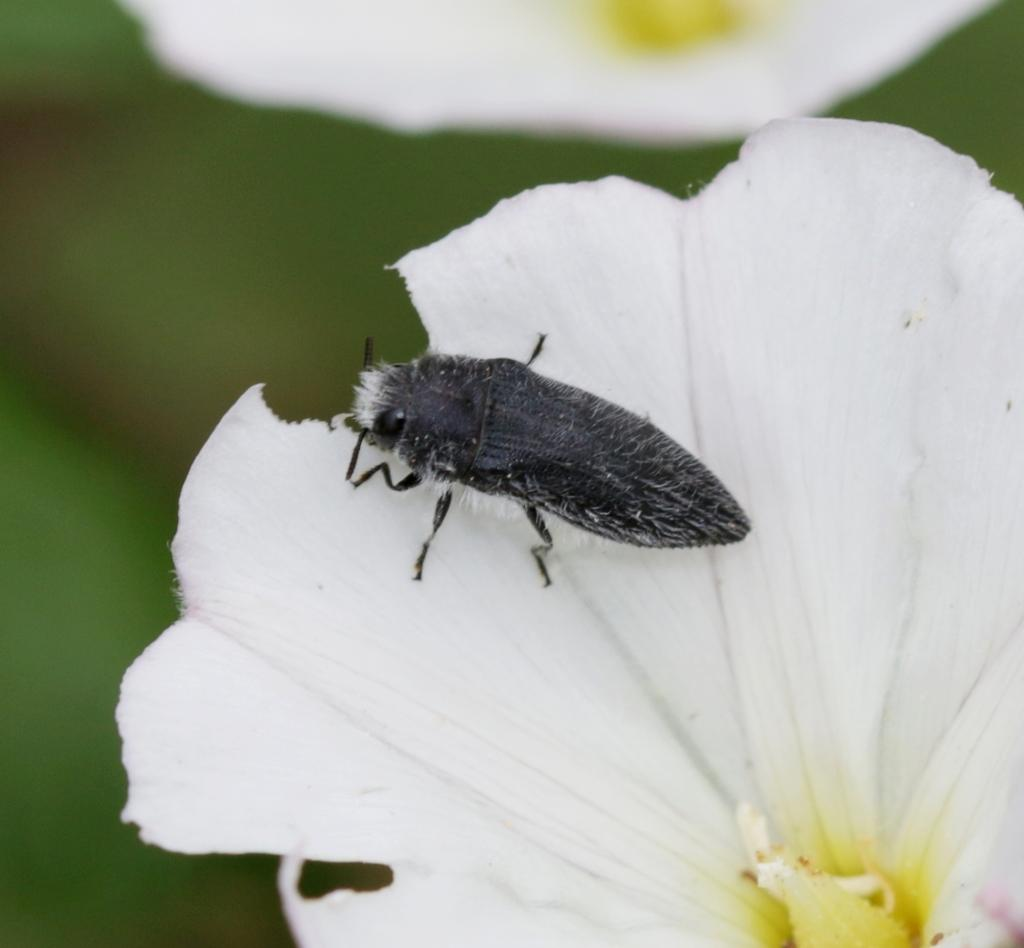How many flowers can be seen in the image? There are two flowers in the image. What is present on one of the flowers? There is a bug on one of the flowers. What can be seen in the background of the image? There are leaves in the background of the image. How would you describe the background of the image? The background is blurry. What color is the chalk used to draw on the tub in the image? There is no tub or chalk present in the image. What happens to the bug when it tries to smash the other flower in the image? There is no indication in the image that the bug is attempting to smash any flowers. 